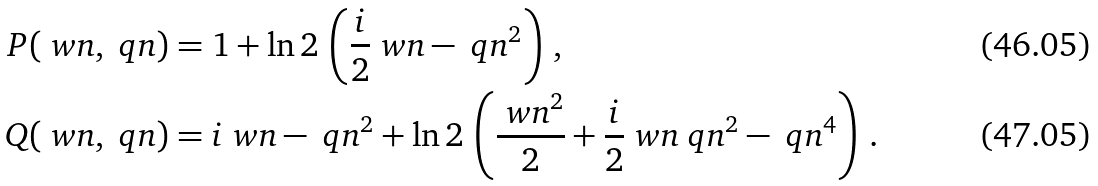Convert formula to latex. <formula><loc_0><loc_0><loc_500><loc_500>P ( \ w n , \ q n ) & = 1 + \ln 2 \, \left ( \frac { i } { 2 } \ w n - \ q n ^ { 2 } \right ) \, , \\ Q ( \ w n , \ q n ) & = i \ w n - \ q n ^ { 2 } + \ln 2 \, \left ( \frac { \ w n ^ { 2 } } 2 + \frac { i } { 2 } \ w n \ q n ^ { 2 } - \ q n ^ { 4 } \right ) \, .</formula> 